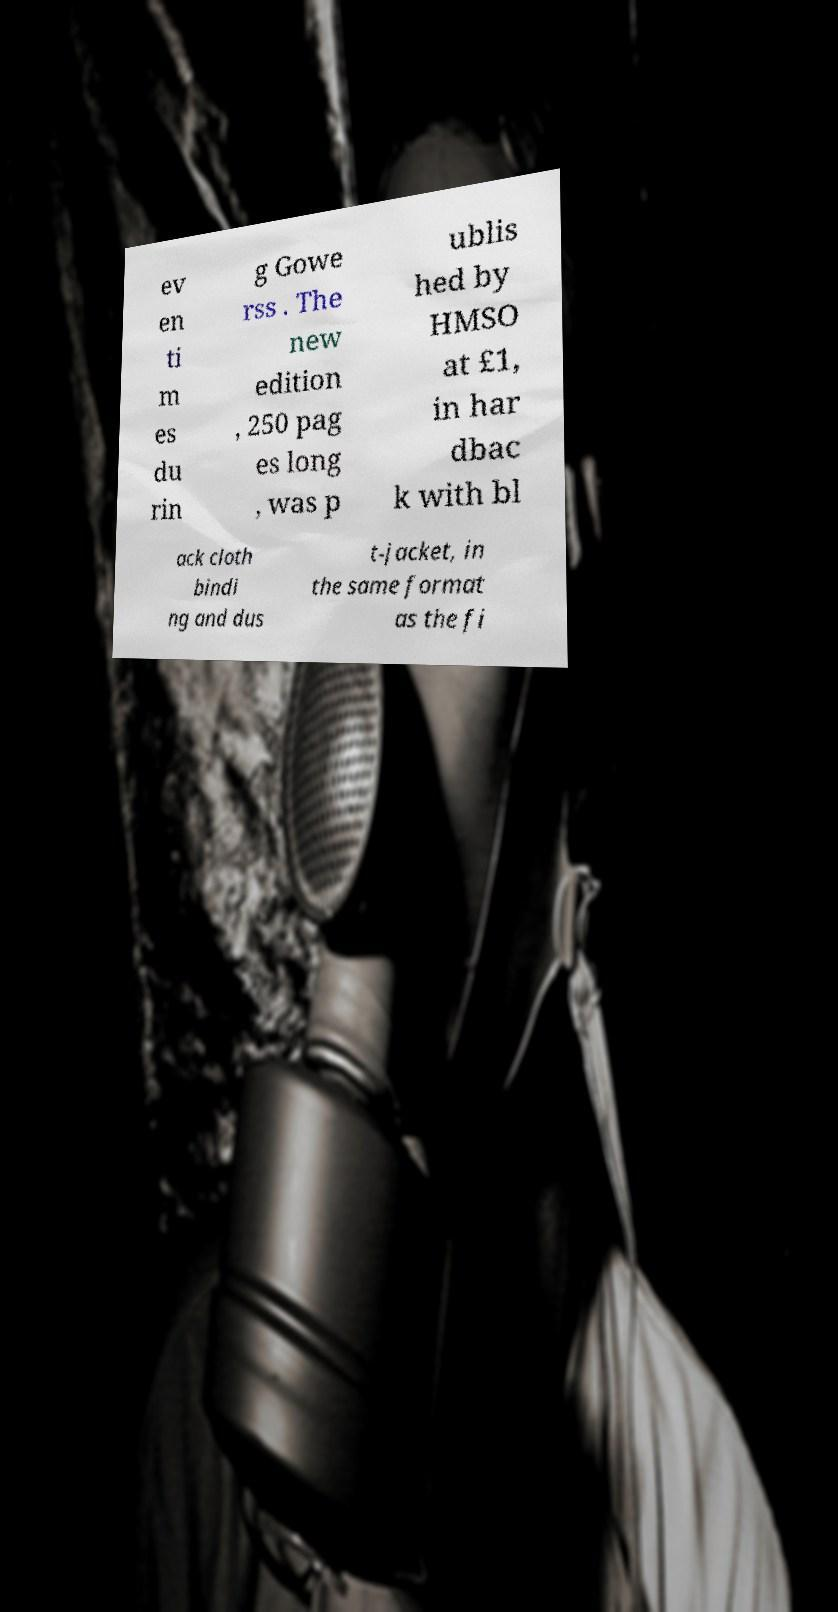Please identify and transcribe the text found in this image. ev en ti m es du rin g Gowe rss . The new edition , 250 pag es long , was p ublis hed by HMSO at £1, in har dbac k with bl ack cloth bindi ng and dus t-jacket, in the same format as the fi 